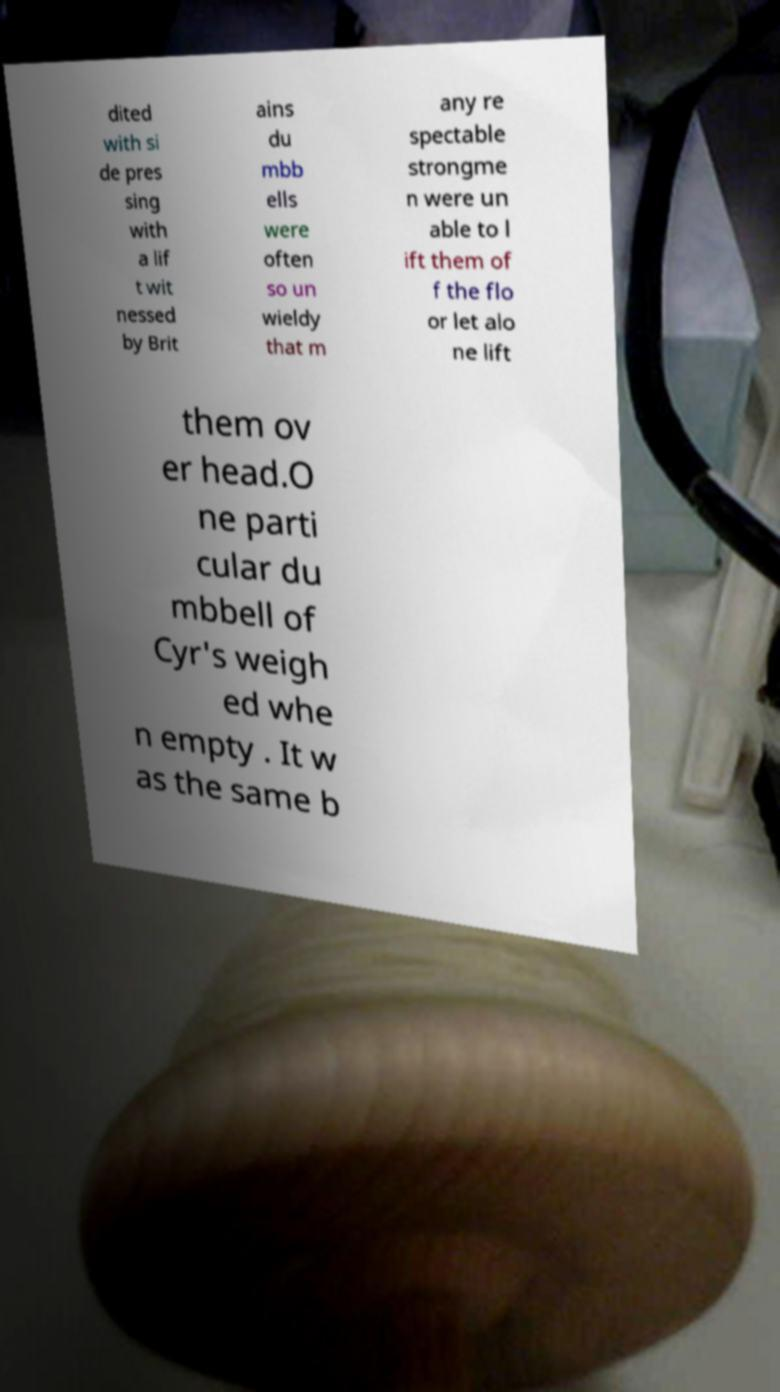I need the written content from this picture converted into text. Can you do that? dited with si de pres sing with a lif t wit nessed by Brit ains du mbb ells were often so un wieldy that m any re spectable strongme n were un able to l ift them of f the flo or let alo ne lift them ov er head.O ne parti cular du mbbell of Cyr's weigh ed whe n empty . It w as the same b 